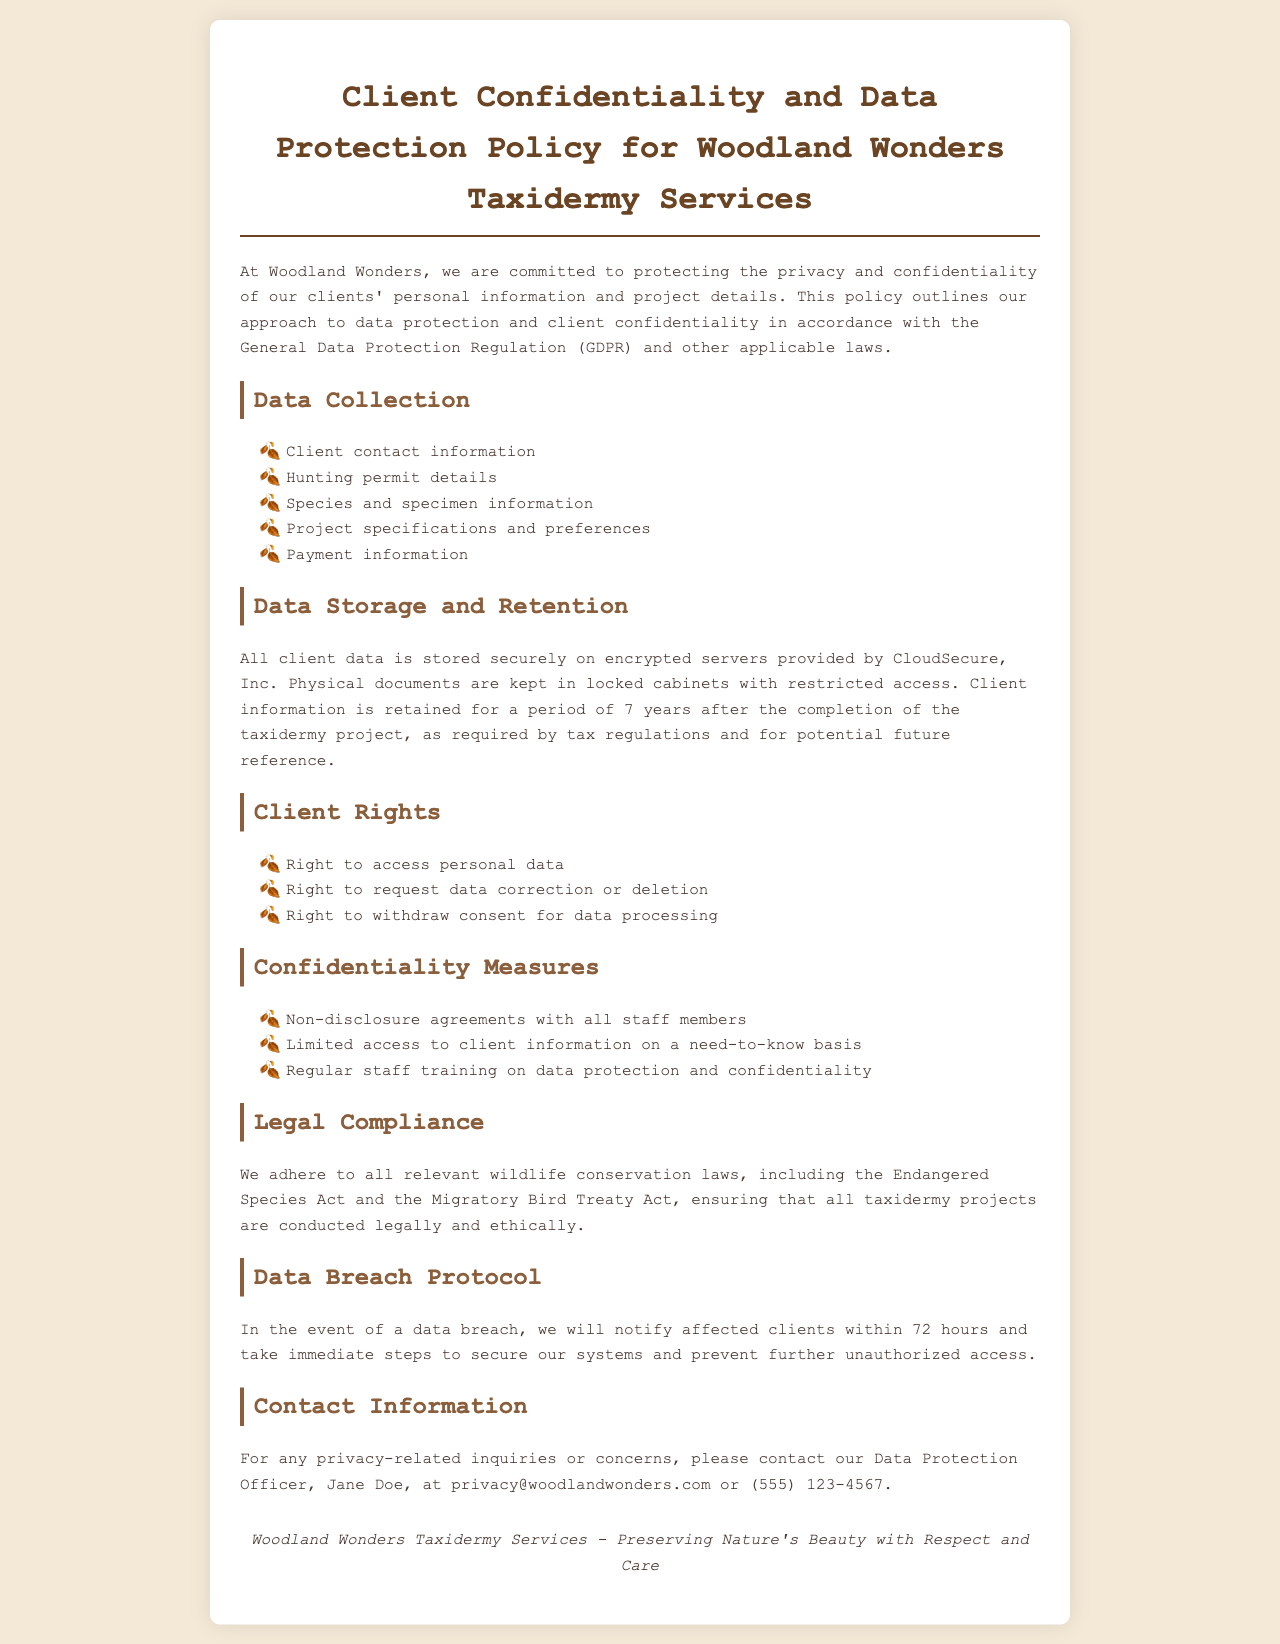What is the title of the policy document? The title of the document is specifically stated at the top of the policy.
Answer: Client Confidentiality and Data Protection Policy for Woodland Wonders Taxidermy Services How long is client information retained? The document specifies the retention period for client information after project completion.
Answer: 7 years Who is the Data Protection Officer? The document includes the contact information for the person responsible for data protection.
Answer: Jane Doe What kind of agreements do staff members sign? The policy outlines the confidentiality measures and specifically mentions agreements that staff are required to sign.
Answer: Non-disclosure agreements What should be done in case of a data breach? The document provides specific steps to be taken in the event of a data breach.
Answer: Notify affected clients within 72 hours What type of laws does Woodland Wonders adhere to? The document mentions legal compliance and specifies types of laws relevant to the services offered.
Answer: Wildlife conservation laws What is the email address for privacy inquiries? The document provides contact information for privacy-related inquiries, including an email address.
Answer: privacy@woodlandwonders.com What security measure is mentioned for data storage? The policy details how client data is stored securely and the type of servers used.
Answer: Encrypted servers 